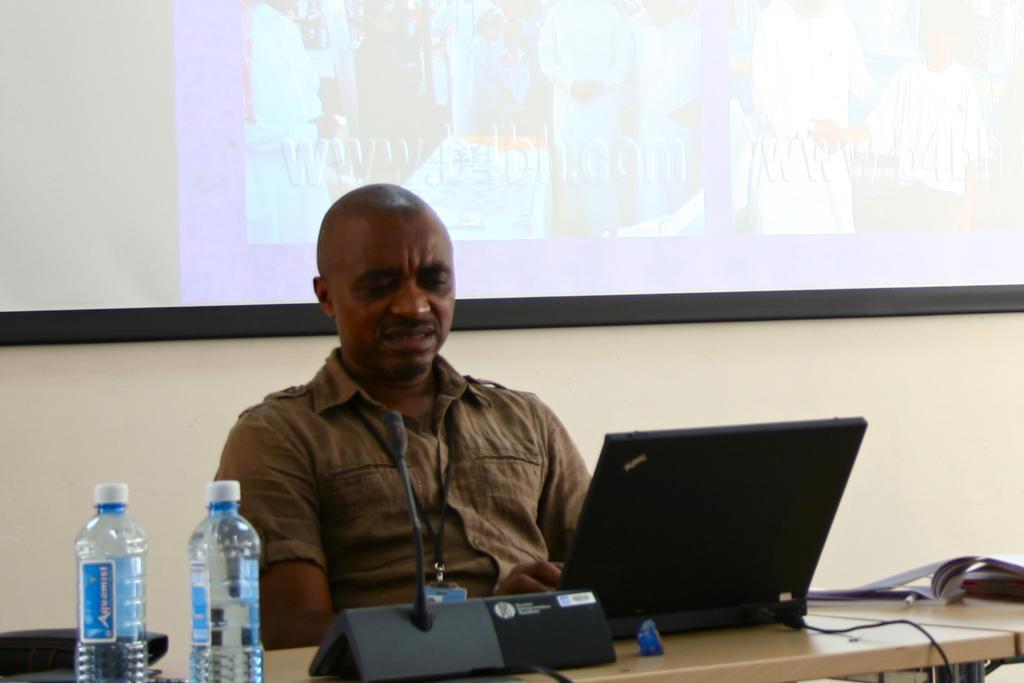Please provide a concise description of this image. In this image there is a person sat on the chair, in front of him there is a table. On the table there is a mic, book, pen, water bottles, laptop, cables and some other objects, behind him there is a screen on the wall. 